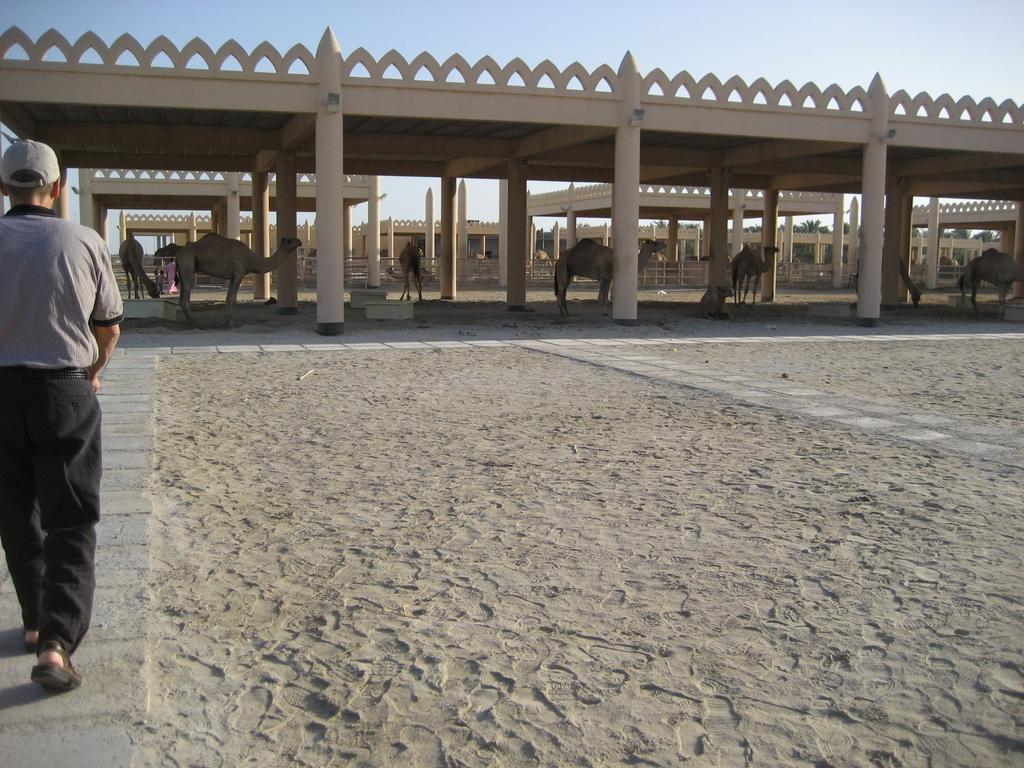What is happening on the left side of the image? There is a person walking on the left side of the image. What can be seen in the middle of the image? There are camels and stables in the middle of the image. What is visible at the top of the image? The sky is visible at the top of the image. What type of coach is being used by the person walking on the left side of the image? There is no coach present in the image; the person is walking on foot. What kind of apparel is the camel wearing in the middle of the image? Camels do not wear apparel, and there are no people or objects on the camels in the image. 